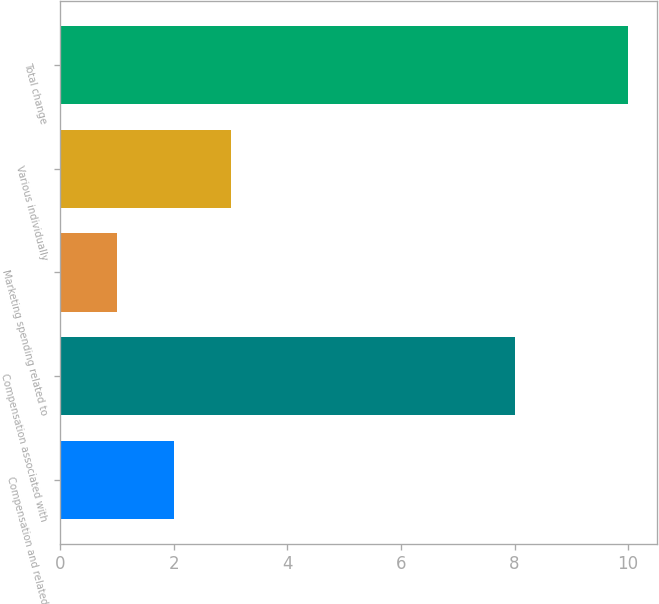Convert chart to OTSL. <chart><loc_0><loc_0><loc_500><loc_500><bar_chart><fcel>Compensation and related<fcel>Compensation associated with<fcel>Marketing spending related to<fcel>Various individually<fcel>Total change<nl><fcel>2<fcel>8<fcel>1<fcel>3<fcel>10<nl></chart> 